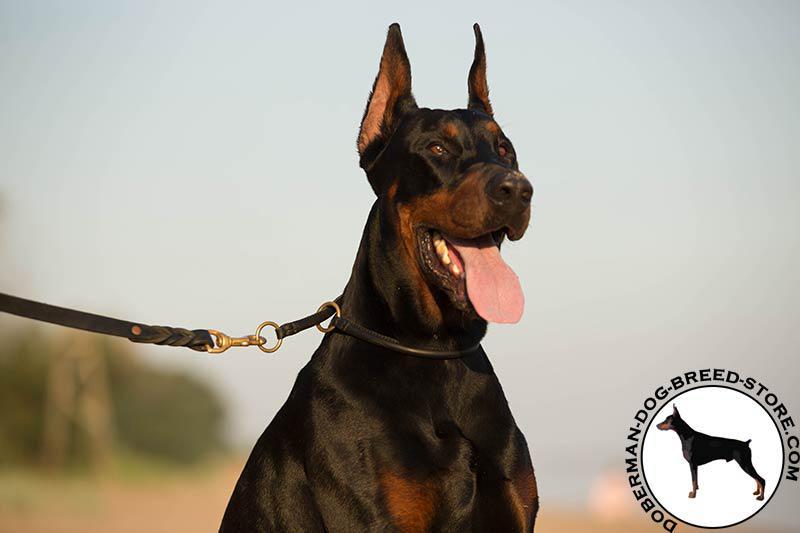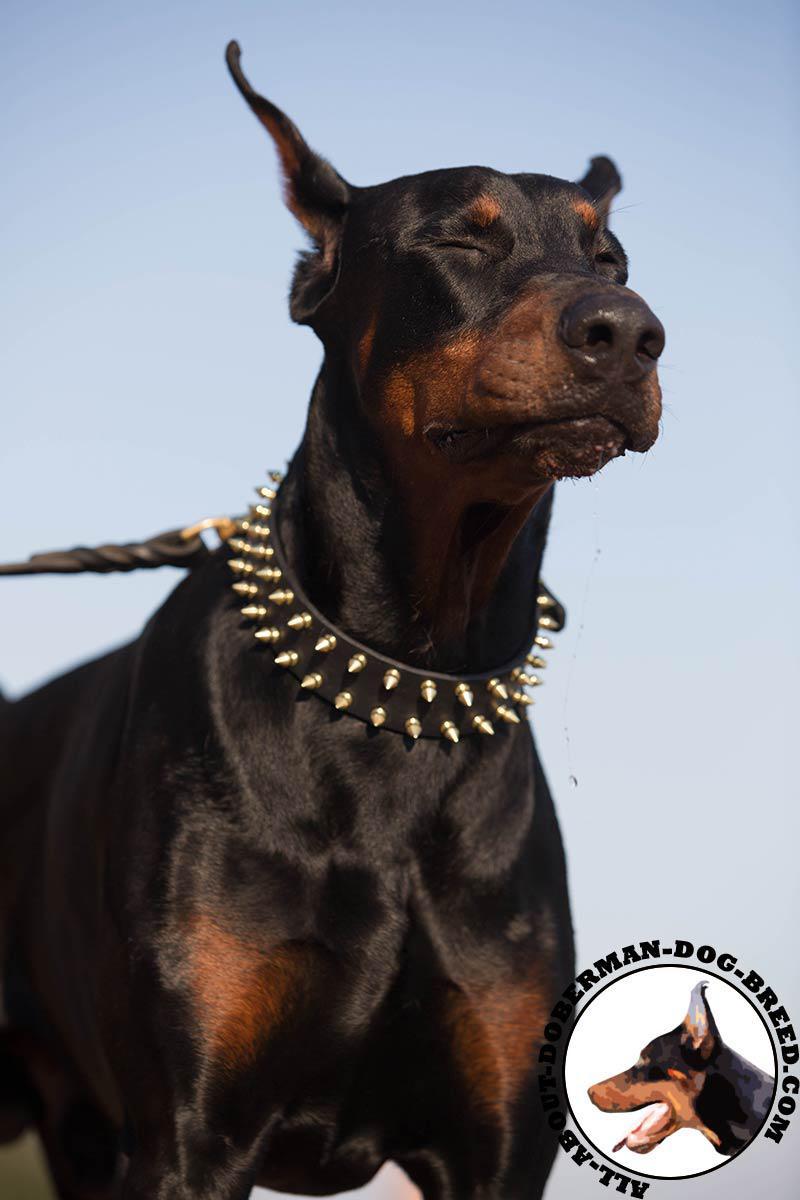The first image is the image on the left, the second image is the image on the right. Examine the images to the left and right. Is the description "One of the dogs is wearing a muzzle." accurate? Answer yes or no. No. The first image is the image on the left, the second image is the image on the right. For the images displayed, is the sentence "Both images contain one dog that is attached the a leash." factually correct? Answer yes or no. Yes. 